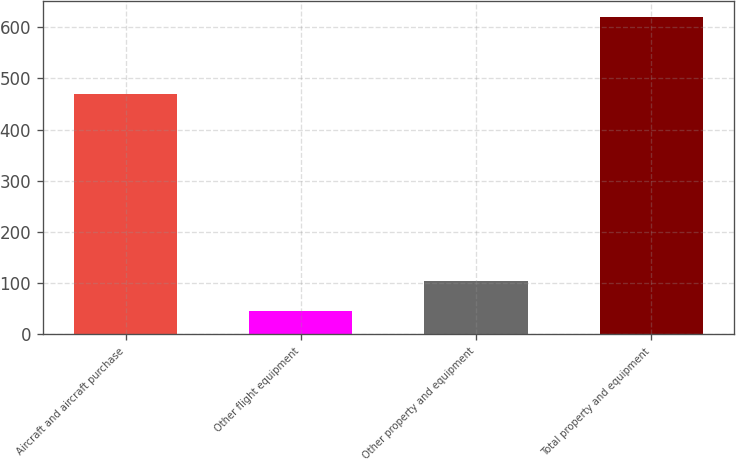Convert chart to OTSL. <chart><loc_0><loc_0><loc_500><loc_500><bar_chart><fcel>Aircraft and aircraft purchase<fcel>Other flight equipment<fcel>Other property and equipment<fcel>Total property and equipment<nl><fcel>470<fcel>45<fcel>105<fcel>620<nl></chart> 